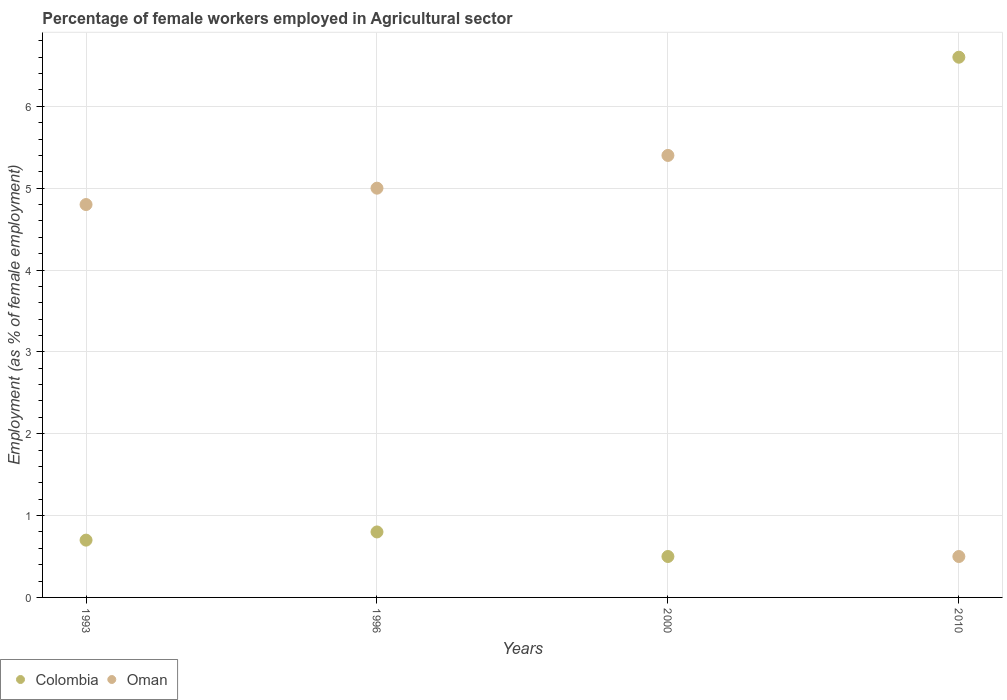Is the number of dotlines equal to the number of legend labels?
Make the answer very short. Yes. Across all years, what is the maximum percentage of females employed in Agricultural sector in Oman?
Ensure brevity in your answer.  5.4. Across all years, what is the minimum percentage of females employed in Agricultural sector in Oman?
Make the answer very short. 0.5. In which year was the percentage of females employed in Agricultural sector in Colombia minimum?
Offer a very short reply. 2000. What is the total percentage of females employed in Agricultural sector in Oman in the graph?
Provide a short and direct response. 15.7. What is the difference between the percentage of females employed in Agricultural sector in Oman in 1993 and that in 2000?
Provide a succinct answer. -0.6. What is the difference between the percentage of females employed in Agricultural sector in Oman in 2000 and the percentage of females employed in Agricultural sector in Colombia in 1996?
Give a very brief answer. 4.6. What is the average percentage of females employed in Agricultural sector in Oman per year?
Provide a succinct answer. 3.93. In the year 2010, what is the difference between the percentage of females employed in Agricultural sector in Colombia and percentage of females employed in Agricultural sector in Oman?
Give a very brief answer. 6.1. In how many years, is the percentage of females employed in Agricultural sector in Colombia greater than 5.6 %?
Keep it short and to the point. 1. What is the ratio of the percentage of females employed in Agricultural sector in Colombia in 1993 to that in 1996?
Offer a very short reply. 0.87. Is the percentage of females employed in Agricultural sector in Colombia in 1993 less than that in 2000?
Your answer should be very brief. No. Is the difference between the percentage of females employed in Agricultural sector in Colombia in 1996 and 2000 greater than the difference between the percentage of females employed in Agricultural sector in Oman in 1996 and 2000?
Ensure brevity in your answer.  Yes. What is the difference between the highest and the second highest percentage of females employed in Agricultural sector in Oman?
Your answer should be very brief. 0.4. What is the difference between the highest and the lowest percentage of females employed in Agricultural sector in Oman?
Keep it short and to the point. 4.9. In how many years, is the percentage of females employed in Agricultural sector in Colombia greater than the average percentage of females employed in Agricultural sector in Colombia taken over all years?
Your response must be concise. 1. Does the percentage of females employed in Agricultural sector in Oman monotonically increase over the years?
Your answer should be very brief. No. Is the percentage of females employed in Agricultural sector in Oman strictly greater than the percentage of females employed in Agricultural sector in Colombia over the years?
Keep it short and to the point. No. Is the percentage of females employed in Agricultural sector in Oman strictly less than the percentage of females employed in Agricultural sector in Colombia over the years?
Your answer should be very brief. No. How many years are there in the graph?
Make the answer very short. 4. What is the difference between two consecutive major ticks on the Y-axis?
Ensure brevity in your answer.  1. Does the graph contain any zero values?
Provide a short and direct response. No. Does the graph contain grids?
Your response must be concise. Yes. Where does the legend appear in the graph?
Offer a very short reply. Bottom left. What is the title of the graph?
Your answer should be very brief. Percentage of female workers employed in Agricultural sector. What is the label or title of the Y-axis?
Provide a short and direct response. Employment (as % of female employment). What is the Employment (as % of female employment) in Colombia in 1993?
Your answer should be compact. 0.7. What is the Employment (as % of female employment) of Oman in 1993?
Provide a succinct answer. 4.8. What is the Employment (as % of female employment) in Colombia in 1996?
Offer a terse response. 0.8. What is the Employment (as % of female employment) in Oman in 1996?
Make the answer very short. 5. What is the Employment (as % of female employment) of Oman in 2000?
Give a very brief answer. 5.4. What is the Employment (as % of female employment) of Colombia in 2010?
Provide a succinct answer. 6.6. Across all years, what is the maximum Employment (as % of female employment) in Colombia?
Ensure brevity in your answer.  6.6. Across all years, what is the maximum Employment (as % of female employment) in Oman?
Provide a succinct answer. 5.4. Across all years, what is the minimum Employment (as % of female employment) of Colombia?
Your response must be concise. 0.5. Across all years, what is the minimum Employment (as % of female employment) of Oman?
Your answer should be very brief. 0.5. What is the total Employment (as % of female employment) of Oman in the graph?
Give a very brief answer. 15.7. What is the difference between the Employment (as % of female employment) in Oman in 1993 and that in 1996?
Your answer should be compact. -0.2. What is the difference between the Employment (as % of female employment) in Oman in 1993 and that in 2000?
Give a very brief answer. -0.6. What is the difference between the Employment (as % of female employment) in Colombia in 1993 and that in 2010?
Keep it short and to the point. -5.9. What is the difference between the Employment (as % of female employment) of Colombia in 1996 and that in 2000?
Your answer should be very brief. 0.3. What is the difference between the Employment (as % of female employment) of Colombia in 1996 and that in 2010?
Give a very brief answer. -5.8. What is the difference between the Employment (as % of female employment) of Colombia in 2000 and that in 2010?
Offer a terse response. -6.1. What is the difference between the Employment (as % of female employment) in Colombia in 1993 and the Employment (as % of female employment) in Oman in 1996?
Keep it short and to the point. -4.3. What is the difference between the Employment (as % of female employment) of Colombia in 1993 and the Employment (as % of female employment) of Oman in 2000?
Offer a terse response. -4.7. What is the difference between the Employment (as % of female employment) in Colombia in 1993 and the Employment (as % of female employment) in Oman in 2010?
Ensure brevity in your answer.  0.2. What is the difference between the Employment (as % of female employment) in Colombia in 1996 and the Employment (as % of female employment) in Oman in 2010?
Provide a succinct answer. 0.3. What is the difference between the Employment (as % of female employment) of Colombia in 2000 and the Employment (as % of female employment) of Oman in 2010?
Offer a very short reply. 0. What is the average Employment (as % of female employment) of Colombia per year?
Ensure brevity in your answer.  2.15. What is the average Employment (as % of female employment) in Oman per year?
Keep it short and to the point. 3.92. In the year 1996, what is the difference between the Employment (as % of female employment) in Colombia and Employment (as % of female employment) in Oman?
Your answer should be very brief. -4.2. What is the ratio of the Employment (as % of female employment) in Colombia in 1993 to that in 1996?
Make the answer very short. 0.88. What is the ratio of the Employment (as % of female employment) in Oman in 1993 to that in 1996?
Make the answer very short. 0.96. What is the ratio of the Employment (as % of female employment) in Colombia in 1993 to that in 2000?
Make the answer very short. 1.4. What is the ratio of the Employment (as % of female employment) in Colombia in 1993 to that in 2010?
Ensure brevity in your answer.  0.11. What is the ratio of the Employment (as % of female employment) of Oman in 1993 to that in 2010?
Your answer should be compact. 9.6. What is the ratio of the Employment (as % of female employment) in Oman in 1996 to that in 2000?
Offer a very short reply. 0.93. What is the ratio of the Employment (as % of female employment) in Colombia in 1996 to that in 2010?
Your response must be concise. 0.12. What is the ratio of the Employment (as % of female employment) of Oman in 1996 to that in 2010?
Keep it short and to the point. 10. What is the ratio of the Employment (as % of female employment) of Colombia in 2000 to that in 2010?
Provide a short and direct response. 0.08. What is the difference between the highest and the second highest Employment (as % of female employment) of Colombia?
Keep it short and to the point. 5.8. What is the difference between the highest and the second highest Employment (as % of female employment) in Oman?
Provide a short and direct response. 0.4. What is the difference between the highest and the lowest Employment (as % of female employment) in Colombia?
Provide a short and direct response. 6.1. What is the difference between the highest and the lowest Employment (as % of female employment) of Oman?
Your answer should be compact. 4.9. 